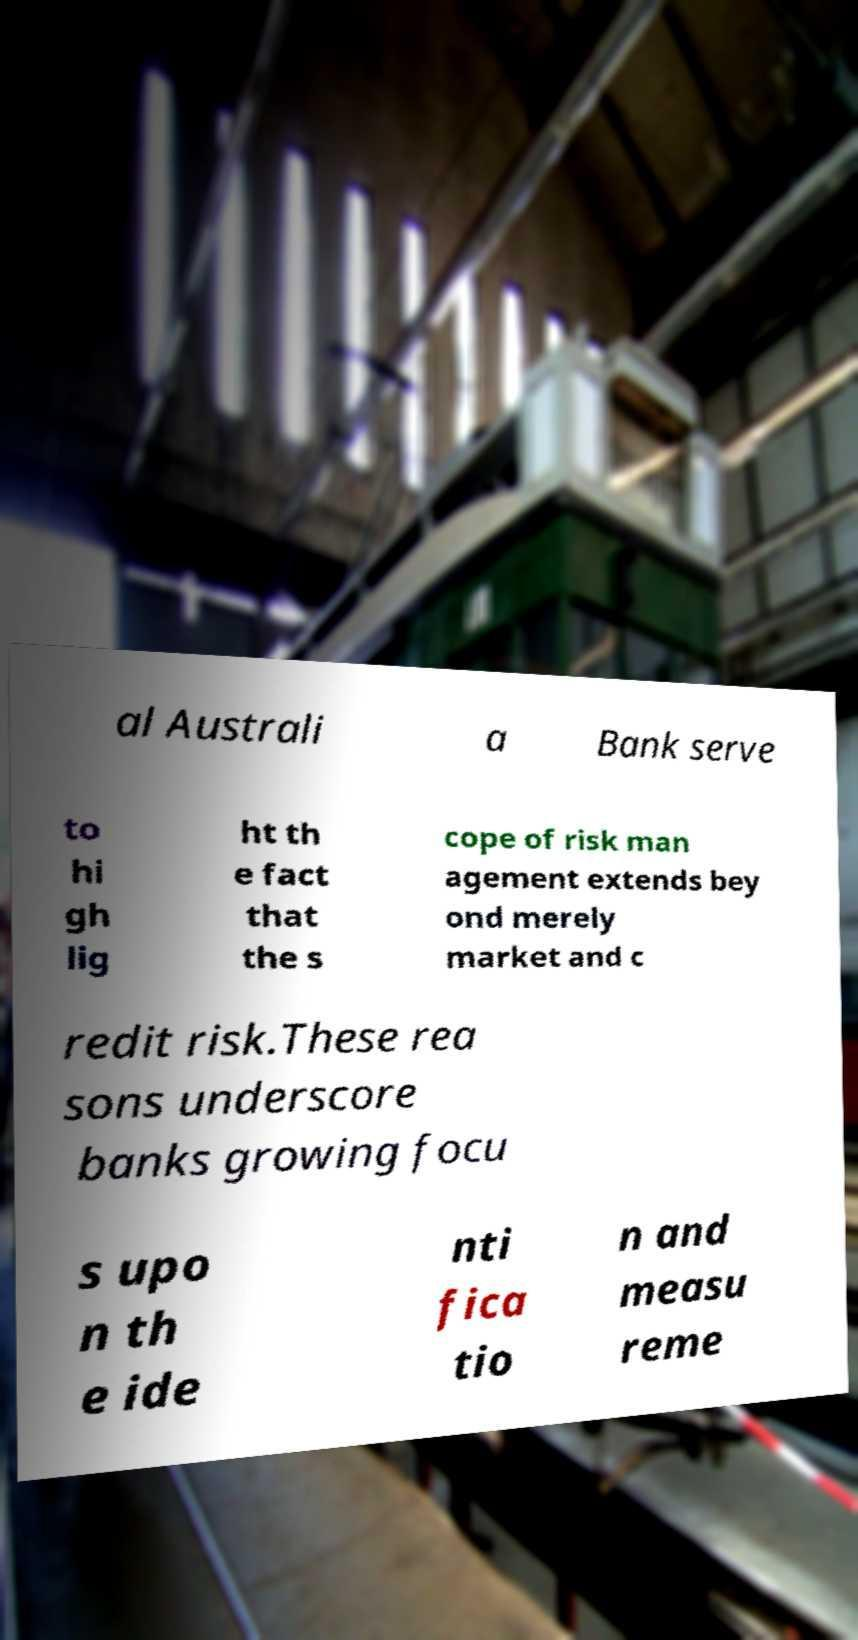Please read and relay the text visible in this image. What does it say? al Australi a Bank serve to hi gh lig ht th e fact that the s cope of risk man agement extends bey ond merely market and c redit risk.These rea sons underscore banks growing focu s upo n th e ide nti fica tio n and measu reme 